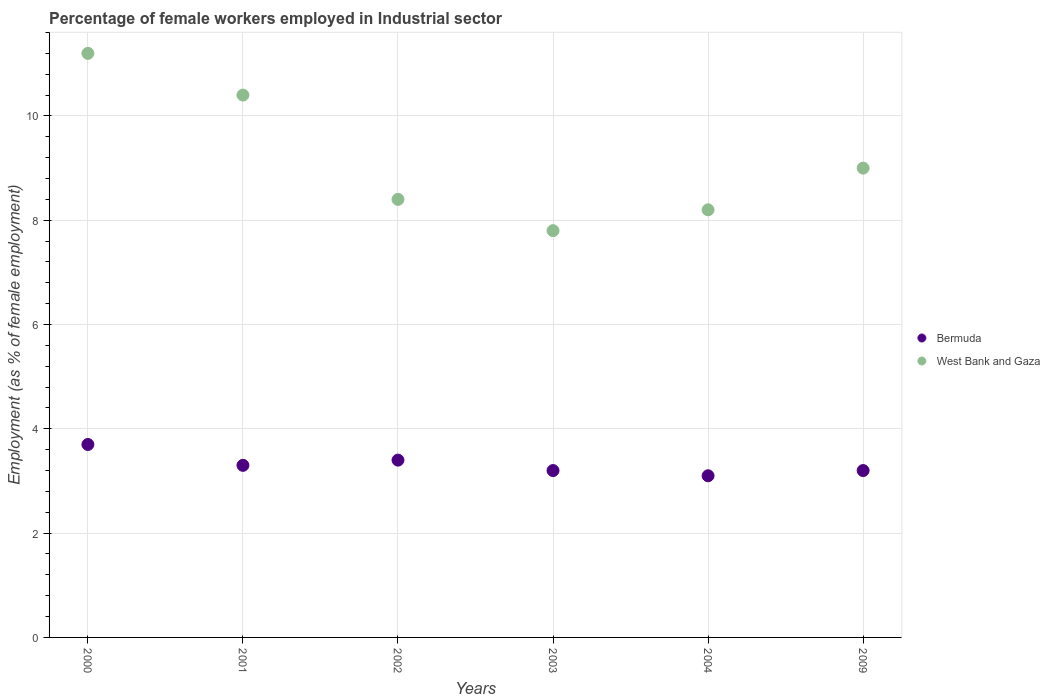What is the percentage of females employed in Industrial sector in West Bank and Gaza in 2009?
Offer a terse response. 9. Across all years, what is the maximum percentage of females employed in Industrial sector in Bermuda?
Your answer should be very brief. 3.7. Across all years, what is the minimum percentage of females employed in Industrial sector in Bermuda?
Keep it short and to the point. 3.1. In which year was the percentage of females employed in Industrial sector in Bermuda maximum?
Keep it short and to the point. 2000. In which year was the percentage of females employed in Industrial sector in West Bank and Gaza minimum?
Ensure brevity in your answer.  2003. What is the total percentage of females employed in Industrial sector in Bermuda in the graph?
Your answer should be compact. 19.9. What is the difference between the percentage of females employed in Industrial sector in Bermuda in 2003 and that in 2004?
Offer a terse response. 0.1. What is the difference between the percentage of females employed in Industrial sector in West Bank and Gaza in 2004 and the percentage of females employed in Industrial sector in Bermuda in 2001?
Provide a short and direct response. 4.9. What is the average percentage of females employed in Industrial sector in West Bank and Gaza per year?
Provide a short and direct response. 9.17. In the year 2001, what is the difference between the percentage of females employed in Industrial sector in Bermuda and percentage of females employed in Industrial sector in West Bank and Gaza?
Your answer should be compact. -7.1. In how many years, is the percentage of females employed in Industrial sector in Bermuda greater than 7.6 %?
Your response must be concise. 0. What is the ratio of the percentage of females employed in Industrial sector in Bermuda in 2000 to that in 2001?
Offer a very short reply. 1.12. Is the percentage of females employed in Industrial sector in West Bank and Gaza in 2003 less than that in 2004?
Provide a succinct answer. Yes. What is the difference between the highest and the second highest percentage of females employed in Industrial sector in West Bank and Gaza?
Ensure brevity in your answer.  0.8. What is the difference between the highest and the lowest percentage of females employed in Industrial sector in West Bank and Gaza?
Provide a short and direct response. 3.4. In how many years, is the percentage of females employed in Industrial sector in Bermuda greater than the average percentage of females employed in Industrial sector in Bermuda taken over all years?
Your answer should be compact. 2. Is the percentage of females employed in Industrial sector in Bermuda strictly greater than the percentage of females employed in Industrial sector in West Bank and Gaza over the years?
Provide a short and direct response. No. Is the percentage of females employed in Industrial sector in West Bank and Gaza strictly less than the percentage of females employed in Industrial sector in Bermuda over the years?
Give a very brief answer. No. How many dotlines are there?
Ensure brevity in your answer.  2. Are the values on the major ticks of Y-axis written in scientific E-notation?
Make the answer very short. No. Does the graph contain grids?
Offer a terse response. Yes. Where does the legend appear in the graph?
Provide a succinct answer. Center right. How many legend labels are there?
Offer a terse response. 2. What is the title of the graph?
Offer a terse response. Percentage of female workers employed in Industrial sector. Does "Bulgaria" appear as one of the legend labels in the graph?
Your answer should be compact. No. What is the label or title of the X-axis?
Offer a terse response. Years. What is the label or title of the Y-axis?
Provide a short and direct response. Employment (as % of female employment). What is the Employment (as % of female employment) in Bermuda in 2000?
Provide a short and direct response. 3.7. What is the Employment (as % of female employment) of West Bank and Gaza in 2000?
Your answer should be very brief. 11.2. What is the Employment (as % of female employment) of Bermuda in 2001?
Provide a short and direct response. 3.3. What is the Employment (as % of female employment) of West Bank and Gaza in 2001?
Your response must be concise. 10.4. What is the Employment (as % of female employment) in Bermuda in 2002?
Keep it short and to the point. 3.4. What is the Employment (as % of female employment) in West Bank and Gaza in 2002?
Offer a terse response. 8.4. What is the Employment (as % of female employment) in Bermuda in 2003?
Offer a very short reply. 3.2. What is the Employment (as % of female employment) in West Bank and Gaza in 2003?
Provide a succinct answer. 7.8. What is the Employment (as % of female employment) of Bermuda in 2004?
Your answer should be very brief. 3.1. What is the Employment (as % of female employment) in West Bank and Gaza in 2004?
Offer a terse response. 8.2. What is the Employment (as % of female employment) in Bermuda in 2009?
Your answer should be very brief. 3.2. Across all years, what is the maximum Employment (as % of female employment) in Bermuda?
Offer a terse response. 3.7. Across all years, what is the maximum Employment (as % of female employment) in West Bank and Gaza?
Make the answer very short. 11.2. Across all years, what is the minimum Employment (as % of female employment) in Bermuda?
Provide a short and direct response. 3.1. Across all years, what is the minimum Employment (as % of female employment) in West Bank and Gaza?
Ensure brevity in your answer.  7.8. What is the total Employment (as % of female employment) of West Bank and Gaza in the graph?
Offer a very short reply. 55. What is the difference between the Employment (as % of female employment) in Bermuda in 2000 and that in 2001?
Offer a very short reply. 0.4. What is the difference between the Employment (as % of female employment) of West Bank and Gaza in 2000 and that in 2001?
Give a very brief answer. 0.8. What is the difference between the Employment (as % of female employment) in Bermuda in 2000 and that in 2002?
Offer a very short reply. 0.3. What is the difference between the Employment (as % of female employment) of Bermuda in 2000 and that in 2009?
Offer a terse response. 0.5. What is the difference between the Employment (as % of female employment) in West Bank and Gaza in 2000 and that in 2009?
Give a very brief answer. 2.2. What is the difference between the Employment (as % of female employment) of Bermuda in 2001 and that in 2002?
Offer a terse response. -0.1. What is the difference between the Employment (as % of female employment) of West Bank and Gaza in 2001 and that in 2002?
Your answer should be compact. 2. What is the difference between the Employment (as % of female employment) of West Bank and Gaza in 2001 and that in 2004?
Your answer should be compact. 2.2. What is the difference between the Employment (as % of female employment) of Bermuda in 2002 and that in 2003?
Offer a very short reply. 0.2. What is the difference between the Employment (as % of female employment) of West Bank and Gaza in 2002 and that in 2004?
Make the answer very short. 0.2. What is the difference between the Employment (as % of female employment) of West Bank and Gaza in 2002 and that in 2009?
Offer a very short reply. -0.6. What is the difference between the Employment (as % of female employment) in West Bank and Gaza in 2003 and that in 2004?
Offer a very short reply. -0.4. What is the difference between the Employment (as % of female employment) of Bermuda in 2003 and that in 2009?
Provide a short and direct response. 0. What is the difference between the Employment (as % of female employment) in West Bank and Gaza in 2003 and that in 2009?
Offer a terse response. -1.2. What is the difference between the Employment (as % of female employment) in Bermuda in 2000 and the Employment (as % of female employment) in West Bank and Gaza in 2002?
Offer a terse response. -4.7. What is the difference between the Employment (as % of female employment) of Bermuda in 2000 and the Employment (as % of female employment) of West Bank and Gaza in 2009?
Make the answer very short. -5.3. What is the difference between the Employment (as % of female employment) in Bermuda in 2001 and the Employment (as % of female employment) in West Bank and Gaza in 2002?
Offer a very short reply. -5.1. What is the difference between the Employment (as % of female employment) in Bermuda in 2001 and the Employment (as % of female employment) in West Bank and Gaza in 2003?
Keep it short and to the point. -4.5. What is the difference between the Employment (as % of female employment) of Bermuda in 2001 and the Employment (as % of female employment) of West Bank and Gaza in 2004?
Provide a short and direct response. -4.9. What is the difference between the Employment (as % of female employment) in Bermuda in 2002 and the Employment (as % of female employment) in West Bank and Gaza in 2003?
Give a very brief answer. -4.4. What is the difference between the Employment (as % of female employment) in Bermuda in 2002 and the Employment (as % of female employment) in West Bank and Gaza in 2004?
Provide a succinct answer. -4.8. What is the difference between the Employment (as % of female employment) of Bermuda in 2002 and the Employment (as % of female employment) of West Bank and Gaza in 2009?
Keep it short and to the point. -5.6. What is the difference between the Employment (as % of female employment) of Bermuda in 2003 and the Employment (as % of female employment) of West Bank and Gaza in 2004?
Keep it short and to the point. -5. What is the difference between the Employment (as % of female employment) of Bermuda in 2003 and the Employment (as % of female employment) of West Bank and Gaza in 2009?
Give a very brief answer. -5.8. What is the difference between the Employment (as % of female employment) in Bermuda in 2004 and the Employment (as % of female employment) in West Bank and Gaza in 2009?
Provide a succinct answer. -5.9. What is the average Employment (as % of female employment) of Bermuda per year?
Your answer should be very brief. 3.32. What is the average Employment (as % of female employment) of West Bank and Gaza per year?
Your answer should be very brief. 9.17. In the year 2002, what is the difference between the Employment (as % of female employment) in Bermuda and Employment (as % of female employment) in West Bank and Gaza?
Your answer should be compact. -5. In the year 2003, what is the difference between the Employment (as % of female employment) in Bermuda and Employment (as % of female employment) in West Bank and Gaza?
Your response must be concise. -4.6. In the year 2009, what is the difference between the Employment (as % of female employment) of Bermuda and Employment (as % of female employment) of West Bank and Gaza?
Ensure brevity in your answer.  -5.8. What is the ratio of the Employment (as % of female employment) in Bermuda in 2000 to that in 2001?
Keep it short and to the point. 1.12. What is the ratio of the Employment (as % of female employment) in Bermuda in 2000 to that in 2002?
Make the answer very short. 1.09. What is the ratio of the Employment (as % of female employment) of West Bank and Gaza in 2000 to that in 2002?
Your answer should be compact. 1.33. What is the ratio of the Employment (as % of female employment) of Bermuda in 2000 to that in 2003?
Offer a terse response. 1.16. What is the ratio of the Employment (as % of female employment) in West Bank and Gaza in 2000 to that in 2003?
Offer a very short reply. 1.44. What is the ratio of the Employment (as % of female employment) of Bermuda in 2000 to that in 2004?
Keep it short and to the point. 1.19. What is the ratio of the Employment (as % of female employment) of West Bank and Gaza in 2000 to that in 2004?
Make the answer very short. 1.37. What is the ratio of the Employment (as % of female employment) of Bermuda in 2000 to that in 2009?
Your answer should be compact. 1.16. What is the ratio of the Employment (as % of female employment) in West Bank and Gaza in 2000 to that in 2009?
Your response must be concise. 1.24. What is the ratio of the Employment (as % of female employment) in Bermuda in 2001 to that in 2002?
Your answer should be very brief. 0.97. What is the ratio of the Employment (as % of female employment) in West Bank and Gaza in 2001 to that in 2002?
Provide a short and direct response. 1.24. What is the ratio of the Employment (as % of female employment) in Bermuda in 2001 to that in 2003?
Ensure brevity in your answer.  1.03. What is the ratio of the Employment (as % of female employment) of West Bank and Gaza in 2001 to that in 2003?
Give a very brief answer. 1.33. What is the ratio of the Employment (as % of female employment) of Bermuda in 2001 to that in 2004?
Keep it short and to the point. 1.06. What is the ratio of the Employment (as % of female employment) of West Bank and Gaza in 2001 to that in 2004?
Offer a terse response. 1.27. What is the ratio of the Employment (as % of female employment) of Bermuda in 2001 to that in 2009?
Give a very brief answer. 1.03. What is the ratio of the Employment (as % of female employment) in West Bank and Gaza in 2001 to that in 2009?
Make the answer very short. 1.16. What is the ratio of the Employment (as % of female employment) of Bermuda in 2002 to that in 2004?
Your answer should be very brief. 1.1. What is the ratio of the Employment (as % of female employment) in West Bank and Gaza in 2002 to that in 2004?
Provide a succinct answer. 1.02. What is the ratio of the Employment (as % of female employment) in Bermuda in 2003 to that in 2004?
Your answer should be very brief. 1.03. What is the ratio of the Employment (as % of female employment) in West Bank and Gaza in 2003 to that in 2004?
Give a very brief answer. 0.95. What is the ratio of the Employment (as % of female employment) of Bermuda in 2003 to that in 2009?
Provide a short and direct response. 1. What is the ratio of the Employment (as % of female employment) in West Bank and Gaza in 2003 to that in 2009?
Give a very brief answer. 0.87. What is the ratio of the Employment (as % of female employment) of Bermuda in 2004 to that in 2009?
Make the answer very short. 0.97. What is the ratio of the Employment (as % of female employment) of West Bank and Gaza in 2004 to that in 2009?
Ensure brevity in your answer.  0.91. What is the difference between the highest and the second highest Employment (as % of female employment) of Bermuda?
Offer a terse response. 0.3. What is the difference between the highest and the second highest Employment (as % of female employment) of West Bank and Gaza?
Offer a terse response. 0.8. 